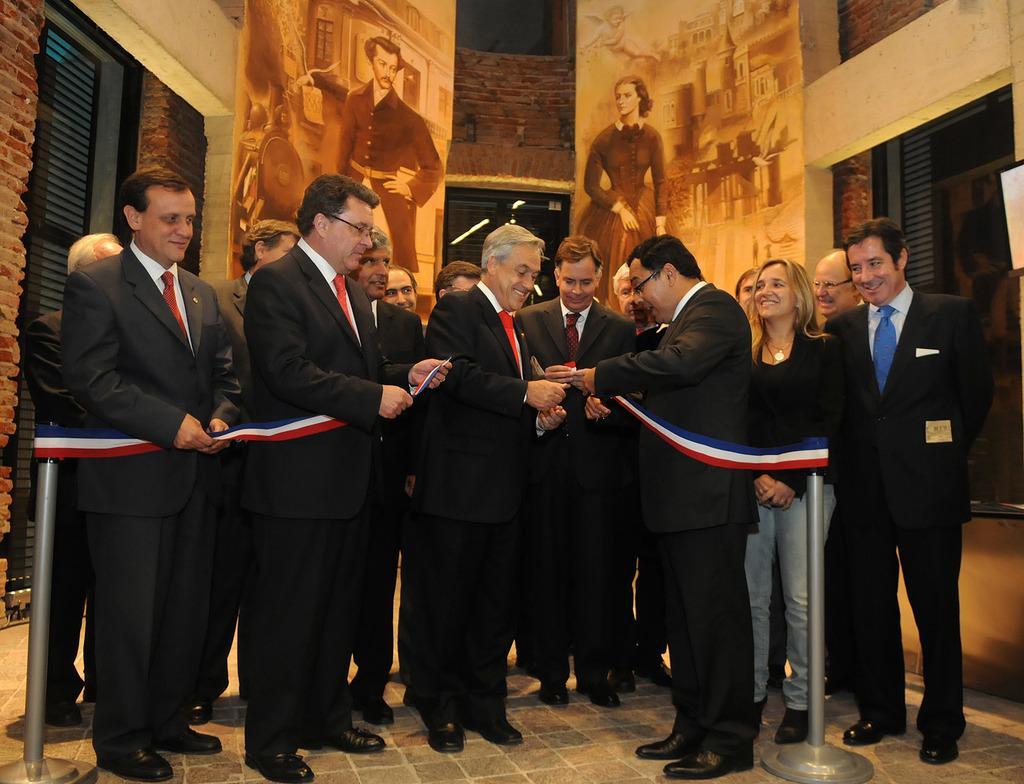In one or two sentences, can you explain what this image depicts? In this image, I can see a group of people standing on the floor and smiling. Among them few people are holding stanchion barrier. In the background, there are posters on the walls and I can see the glass windows. 